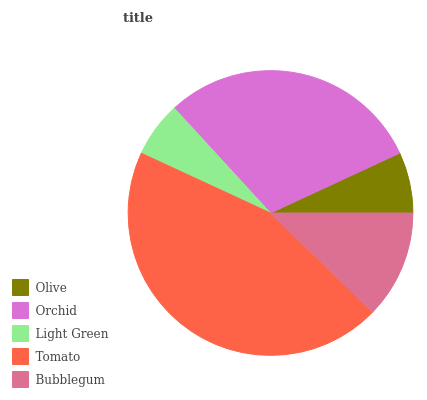Is Light Green the minimum?
Answer yes or no. Yes. Is Tomato the maximum?
Answer yes or no. Yes. Is Orchid the minimum?
Answer yes or no. No. Is Orchid the maximum?
Answer yes or no. No. Is Orchid greater than Olive?
Answer yes or no. Yes. Is Olive less than Orchid?
Answer yes or no. Yes. Is Olive greater than Orchid?
Answer yes or no. No. Is Orchid less than Olive?
Answer yes or no. No. Is Bubblegum the high median?
Answer yes or no. Yes. Is Bubblegum the low median?
Answer yes or no. Yes. Is Light Green the high median?
Answer yes or no. No. Is Olive the low median?
Answer yes or no. No. 